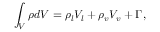Convert formula to latex. <formula><loc_0><loc_0><loc_500><loc_500>\int _ { V } \rho d V = \rho _ { l } V _ { l } + \rho _ { v } V _ { v } + \Gamma ,</formula> 